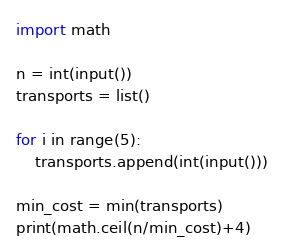Convert code to text. <code><loc_0><loc_0><loc_500><loc_500><_Python_>import math

n = int(input())
transports = list()

for i in range(5):
    transports.append(int(input()))
    
min_cost = min(transports)
print(math.ceil(n/min_cost)+4)</code> 